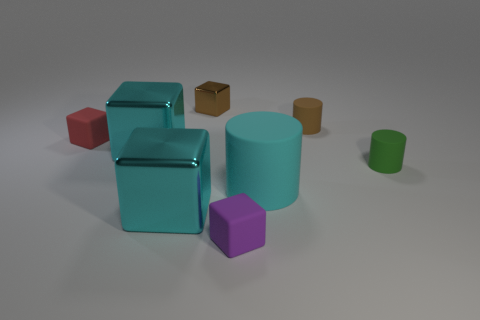How many cyan blocks must be subtracted to get 1 cyan blocks? 1 Subtract all cyan blocks. How many blocks are left? 3 Subtract all tiny brown cubes. How many cubes are left? 4 Add 1 small green matte cylinders. How many objects exist? 9 Subtract all green blocks. Subtract all blue spheres. How many blocks are left? 5 Subtract all cylinders. How many objects are left? 5 Add 8 red things. How many red things are left? 9 Add 7 metal objects. How many metal objects exist? 10 Subtract 0 yellow cubes. How many objects are left? 8 Subtract all tiny matte cylinders. Subtract all matte things. How many objects are left? 1 